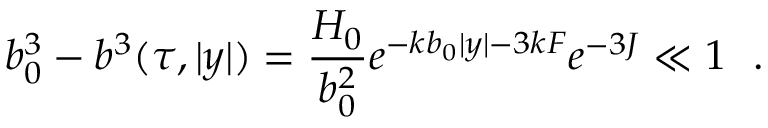Convert formula to latex. <formula><loc_0><loc_0><loc_500><loc_500>b _ { 0 } ^ { 3 } - b ^ { 3 } ( \tau , | y | ) = \frac { H _ { 0 } } { b _ { 0 } ^ { 2 } } e ^ { - k b _ { 0 } | y | - 3 k F } e ^ { - 3 J } \ll 1 .</formula> 